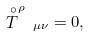Convert formula to latex. <formula><loc_0><loc_0><loc_500><loc_500>\stackrel { \circ } { T } ^ { \rho } \, _ { \mu \nu } = 0 ,</formula> 